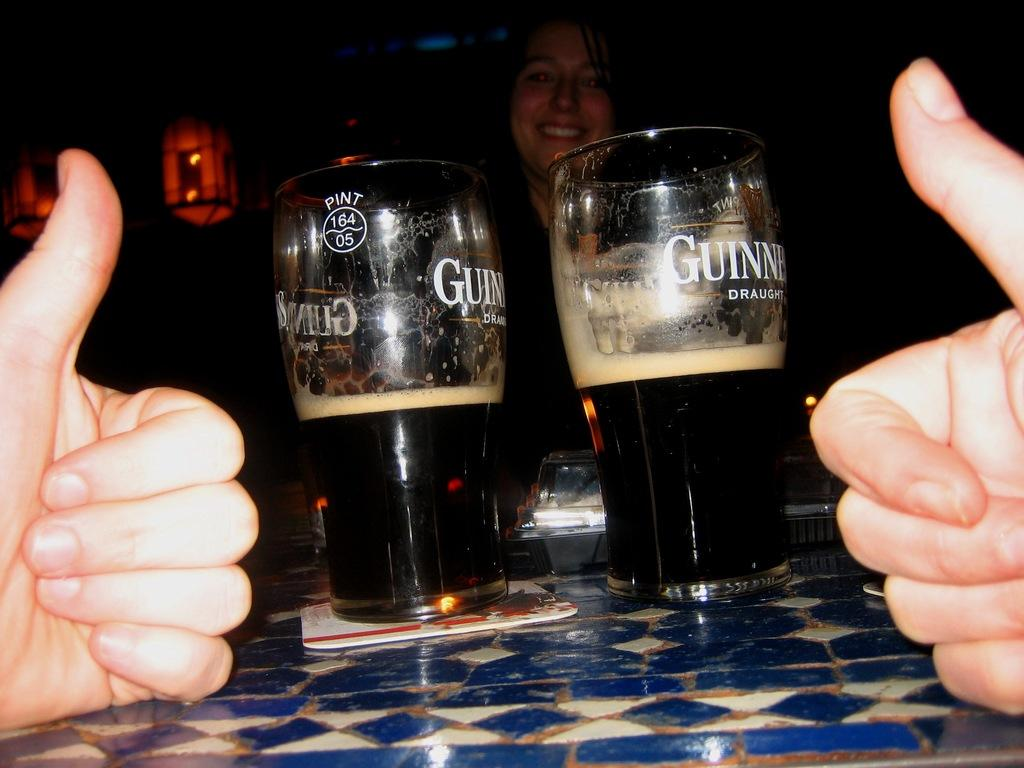<image>
Create a compact narrative representing the image presented. Two half full glasses of Guinness ale sit on a table. 